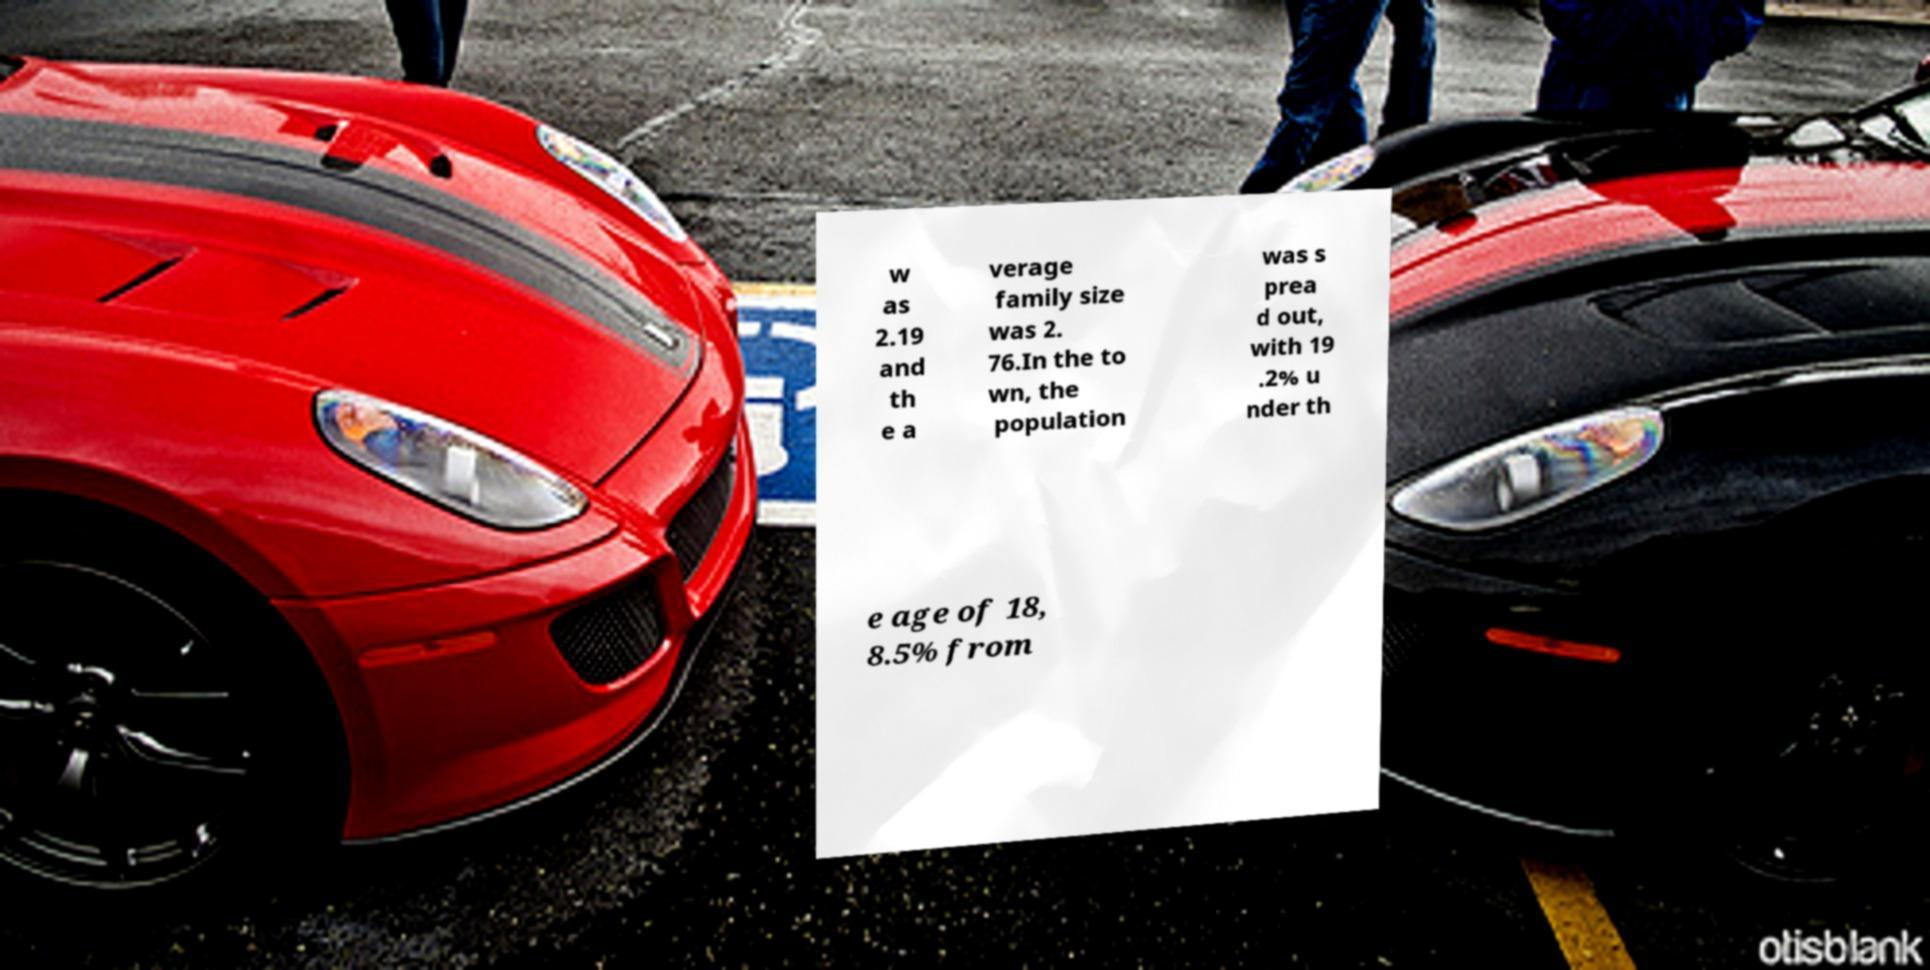What messages or text are displayed in this image? I need them in a readable, typed format. w as 2.19 and th e a verage family size was 2. 76.In the to wn, the population was s prea d out, with 19 .2% u nder th e age of 18, 8.5% from 